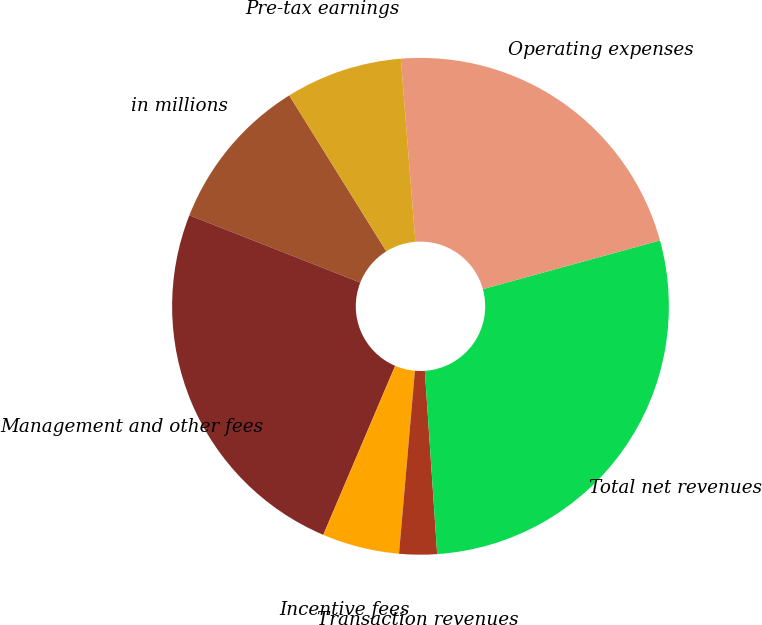Convert chart to OTSL. <chart><loc_0><loc_0><loc_500><loc_500><pie_chart><fcel>in millions<fcel>Management and other fees<fcel>Incentive fees<fcel>Transaction revenues<fcel>Total net revenues<fcel>Operating expenses<fcel>Pre-tax earnings<nl><fcel>10.17%<fcel>24.57%<fcel>5.02%<fcel>2.45%<fcel>28.2%<fcel>21.99%<fcel>7.6%<nl></chart> 